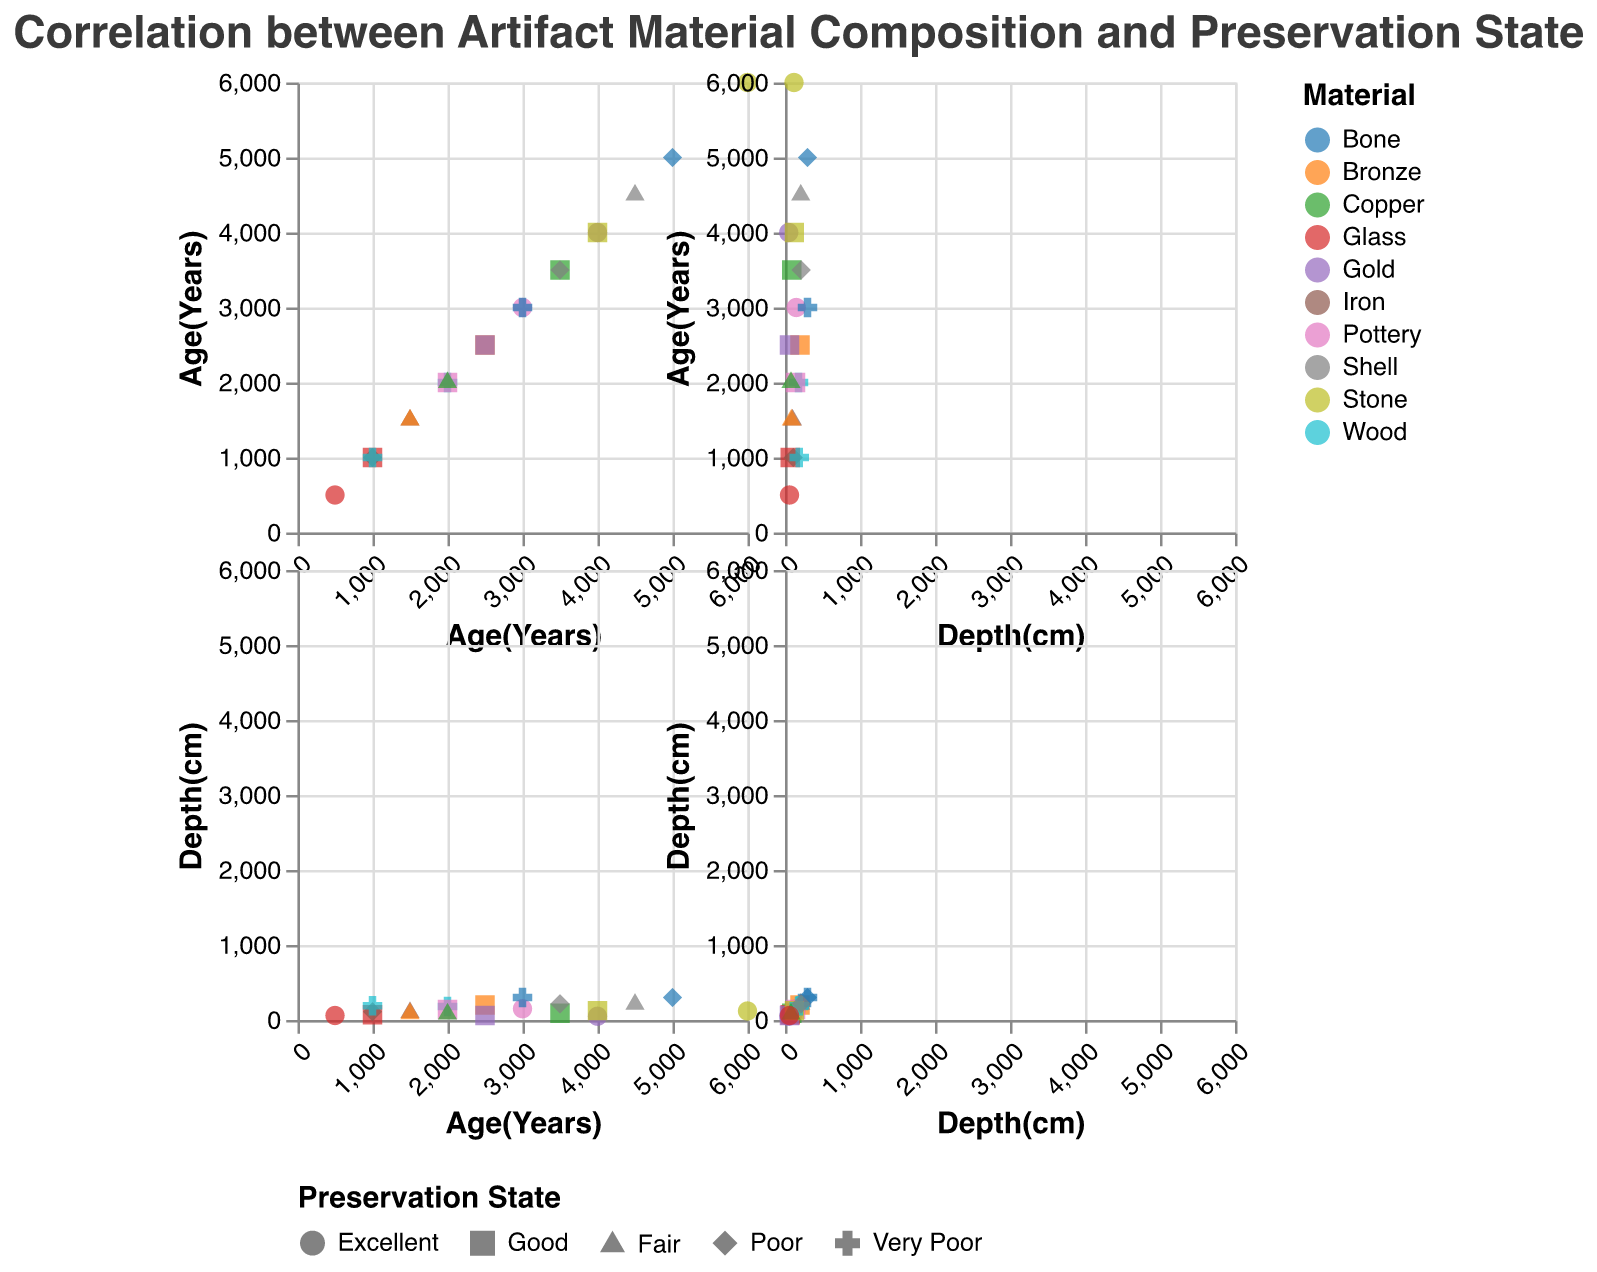How many artifacts are plotted in the figure? To determine the number of artifacts plotted, count each individual data point represented by different shapes and colors. This count corresponds to the number of rows in the data table.
Answer: 20 What is the material with the best preservation state at the shallowest depth? Look for the shape corresponding to "Excellent" (circle shape) at the shallowest depth, which is represented on the x-axis of the scatter plot matrix. The color of this data point indicates the material.
Answer: Gold Which artifacts have a preservation state of "Poor" and what are their depths? Identify data points with the "diamond" shape, which represents "Poor" preservation state. Then, read the associated depths on the axis.
Answer: Bone (300 cm), Shell (215 cm), Iron (110 cm) What is the average depth of artifacts with an "Excellent" preservation state? First, identify the artifacts with an "Excellent" preservation state (circle shape). Then, sum their depths and divide by the number of such artifacts: (150 + 50 + 120 + 60) / 4.
Answer: 95 cm Compare the age distribution of Pottery artifacts with different preservation states. Find the data points representing "Pottery" figures (same color) and observe the ages. Compare the ages with respect to their preservation states.
Answer: Excellent: 3000 years; Good: 2000 years Do Gold and Copper artifacts have comparable depths? Locate the data points with colors representing "Gold" and "Copper," then compare their depths values on the axis.
Answer: Gold: depths 50 cm and 60 cm; Copper: depths 90 cm and 80 cm. They are not exactly comparable but are within a similar range Which artifacts are the oldest and at what depth are they found? Identify the artifact with the highest age value on the scatter plot matrix and note the associated depth.
Answer: Stone, 6000 years, 120 cm Is there a visible trend between artifact age and preservation state? Observe the shapes representing preservation states against the age axis to see if older artifacts tend to have a particular preservation state more often. For instance, if older artifacts (right side) are generally different shapes indicating lower or better states.
Answer: No, there is no clear trend How many artifacts are there with a "Fair" preservation state, and which materials are they made from? Count the data points with the "triangle" shape (indicating "Fair" preservation state) and note the corresponding colors for materials.
Answer: Four artifacts: Iron, Shell, Bronze, Copper Which artifact material has the widest range of depth values? Compare the range (difference between the maximum and minimum values) of depths among different materials by observing the respective data points and their depth values.
Answer: Bone (300 cm range) 